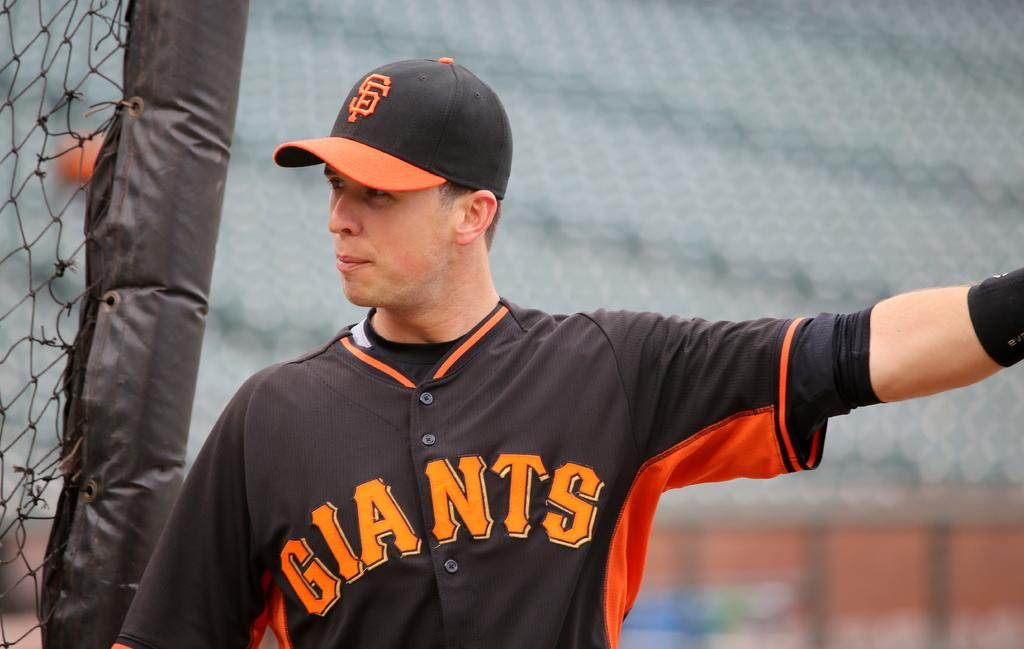<image>
Create a compact narrative representing the image presented. A Giants baseball player stands and makes a gesture. 